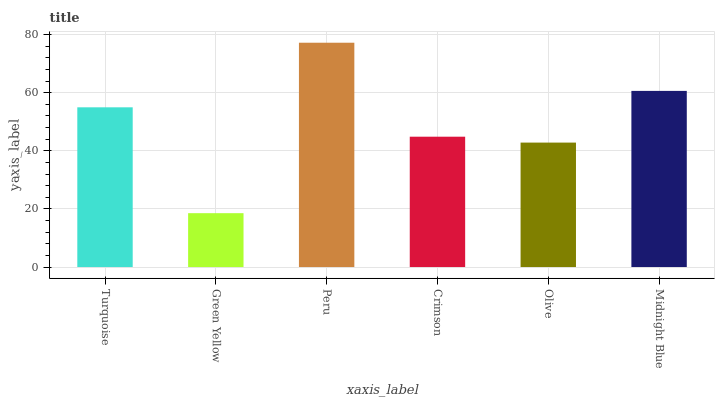Is Peru the minimum?
Answer yes or no. No. Is Green Yellow the maximum?
Answer yes or no. No. Is Peru greater than Green Yellow?
Answer yes or no. Yes. Is Green Yellow less than Peru?
Answer yes or no. Yes. Is Green Yellow greater than Peru?
Answer yes or no. No. Is Peru less than Green Yellow?
Answer yes or no. No. Is Turquoise the high median?
Answer yes or no. Yes. Is Crimson the low median?
Answer yes or no. Yes. Is Olive the high median?
Answer yes or no. No. Is Midnight Blue the low median?
Answer yes or no. No. 